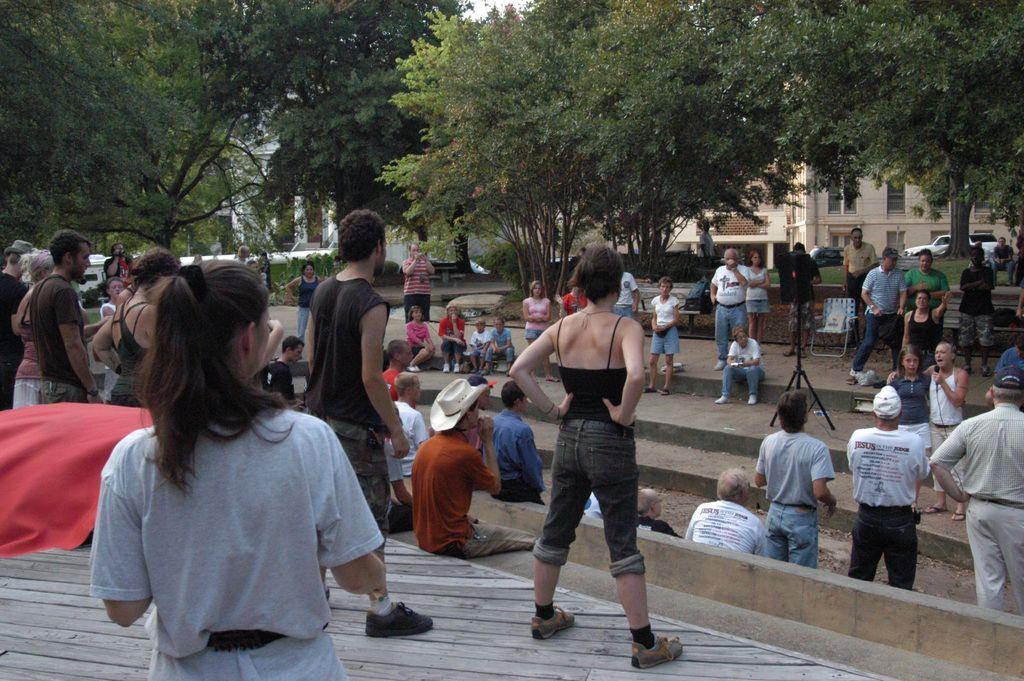How would you summarize this image in a sentence or two? In this image there are a few people standing and some other people sitting on the concrete fences, besides them there are some objects, chairs, stands, behind them there are trees and buildings and there are cars. 